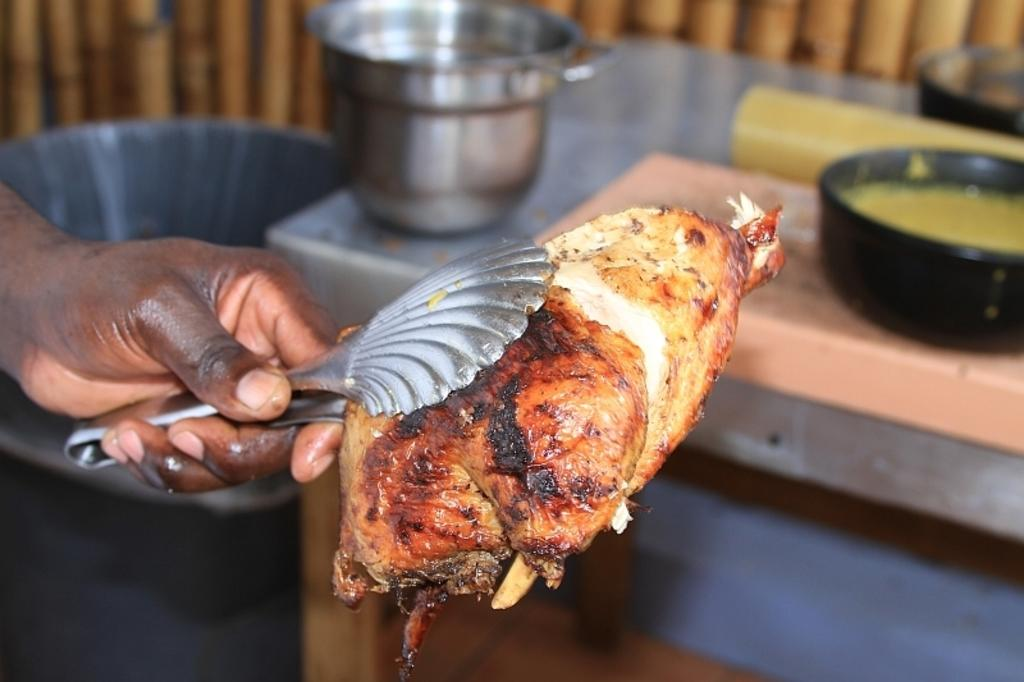What is the main subject of the image? There is a human in the image. What is the human holding in the image? The human is holding a piece of meat. How is the human holding the piece of meat? The human is using an instrument to hold the meat. How does the duck contribute to the human's profit in the image? There is no duck present in the image, and therefore no contribution to the human's profit can be observed. 